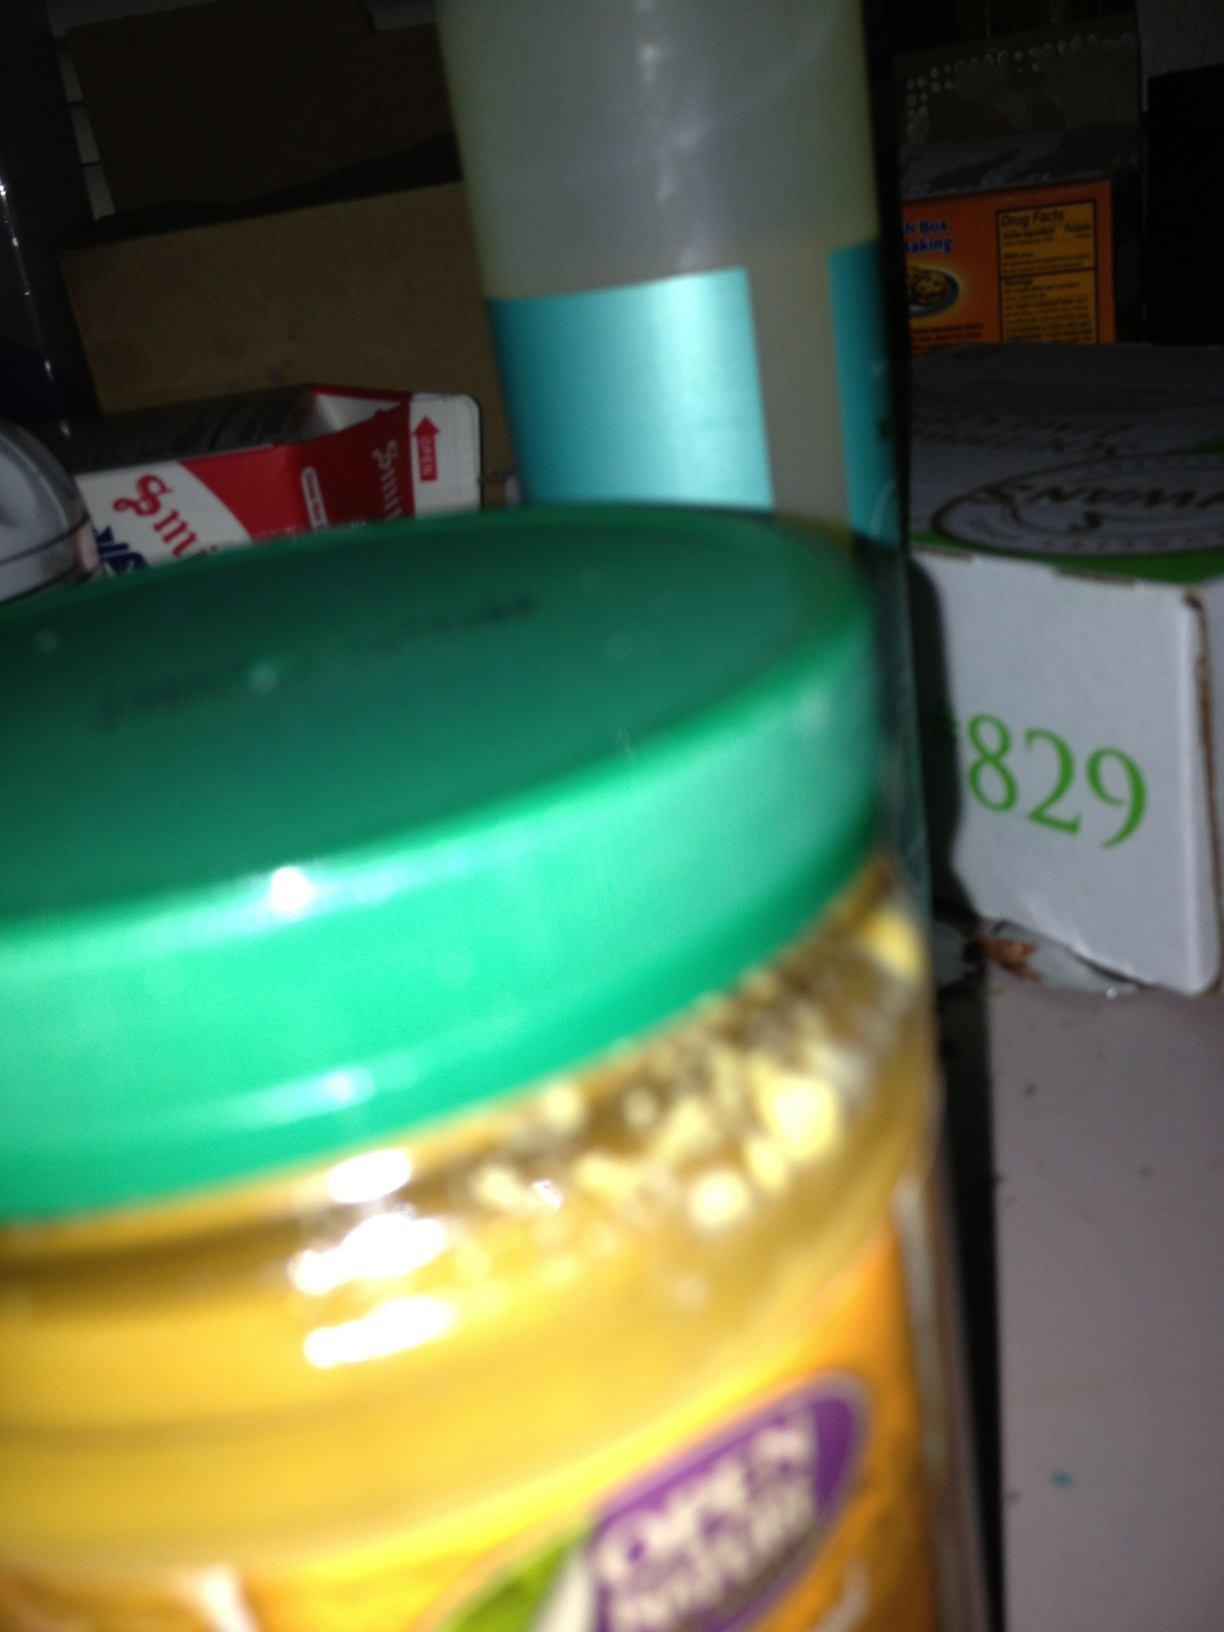can you tell what's in this jar? Unfortunately, due to the angle and blurriness of the image, identifying the exact contents of the jar is challenging. It appears to be a creamy substance with granules, which could suggest something like a grainy mustard or a similar condiment, but without a clearer image or further context, I can't provide a definitive answer. 